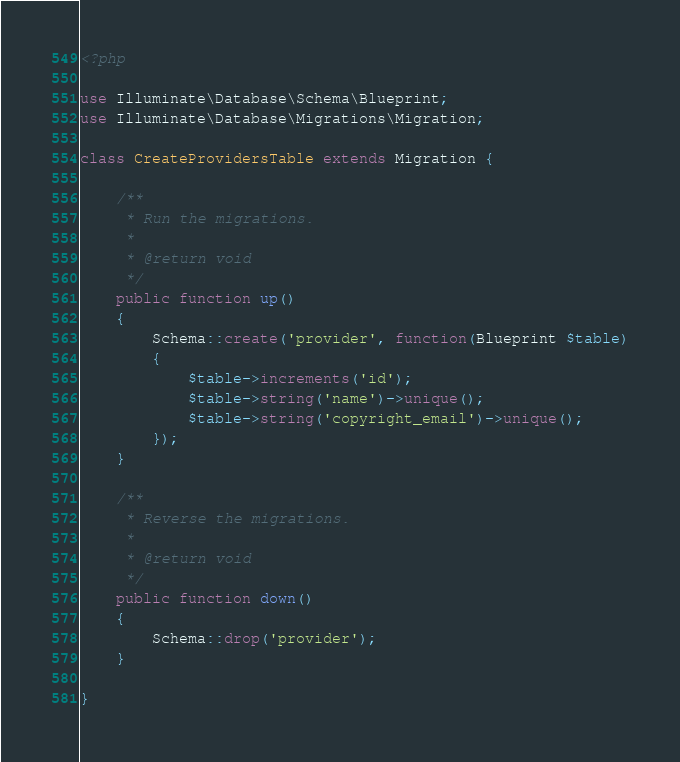Convert code to text. <code><loc_0><loc_0><loc_500><loc_500><_PHP_><?php

use Illuminate\Database\Schema\Blueprint;
use Illuminate\Database\Migrations\Migration;

class CreateProvidersTable extends Migration {

	/**
	 * Run the migrations.
	 *
	 * @return void
	 */
	public function up()
	{
		Schema::create('provider', function(Blueprint $table)
		{
			$table->increments('id');
			$table->string('name')->unique();
            $table->string('copyright_email')->unique();
		});
	}

	/**
	 * Reverse the migrations.
	 *
	 * @return void
	 */
	public function down()
	{
		Schema::drop('provider');
	}

}
</code> 